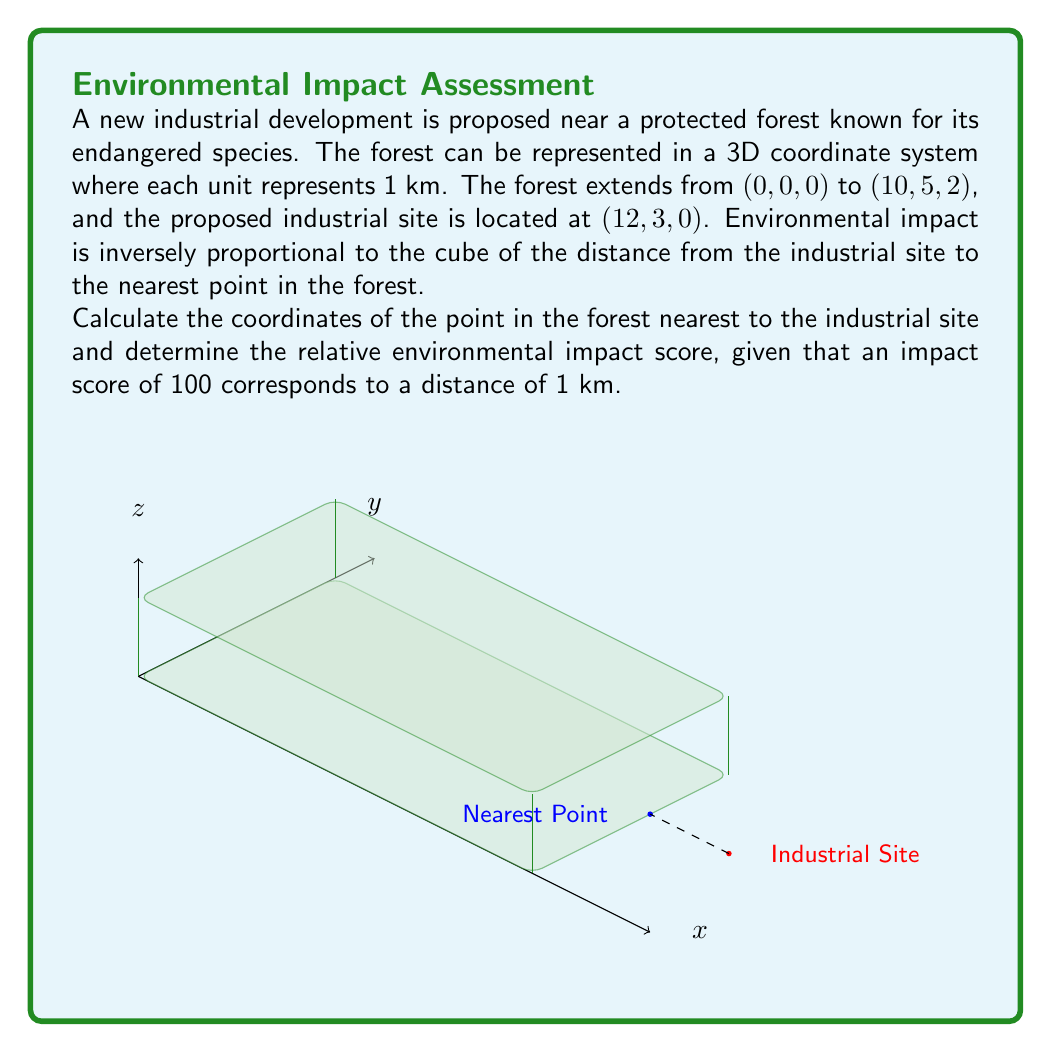Help me with this question. Let's approach this step-by-step:

1) The nearest point in the forest to the industrial site will be on the face of the forest closest to the site. In this case, it's the face at x = 10.

2) The y and z coordinates of this point will be the same as the industrial site's, unless they fall outside the forest's dimensions. So:
   - y coordinate will be 3 (same as industrial site)
   - z coordinate will be 0 (same as industrial site, and within forest's z range of 0 to 2)

3) Therefore, the nearest point in the forest is (10, 3, 0).

4) To calculate the distance between the industrial site (12, 3, 0) and the nearest forest point (10, 3, 0):

   $$d = \sqrt{(12-10)^2 + (3-3)^2 + (0-0)^2} = \sqrt{4} = 2$$ km

5) The impact score is inversely proportional to the cube of the distance. If a distance of 1 km corresponds to a score of 100, then:

   $$\text{Impact Score} = 100 \cdot \left(\frac{1}{d}\right)^3$$

6) Substituting our distance of 2 km:

   $$\text{Impact Score} = 100 \cdot \left(\frac{1}{2}\right)^3 = 100 \cdot \frac{1}{8} = 12.5$$
Answer: Nearest point: (10,3,0); Impact score: 12.5 